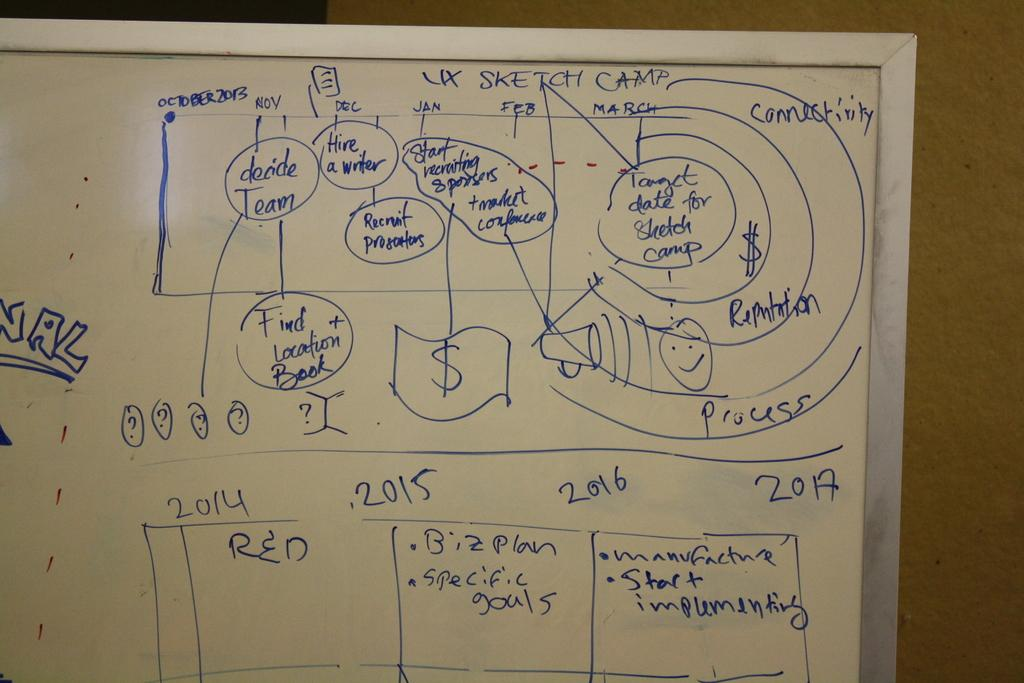<image>
Relay a brief, clear account of the picture shown. A drawing of a business chart is shown including wordings such as Biz plan, Start Recruiting Sponsers, and Hire a Writer. 